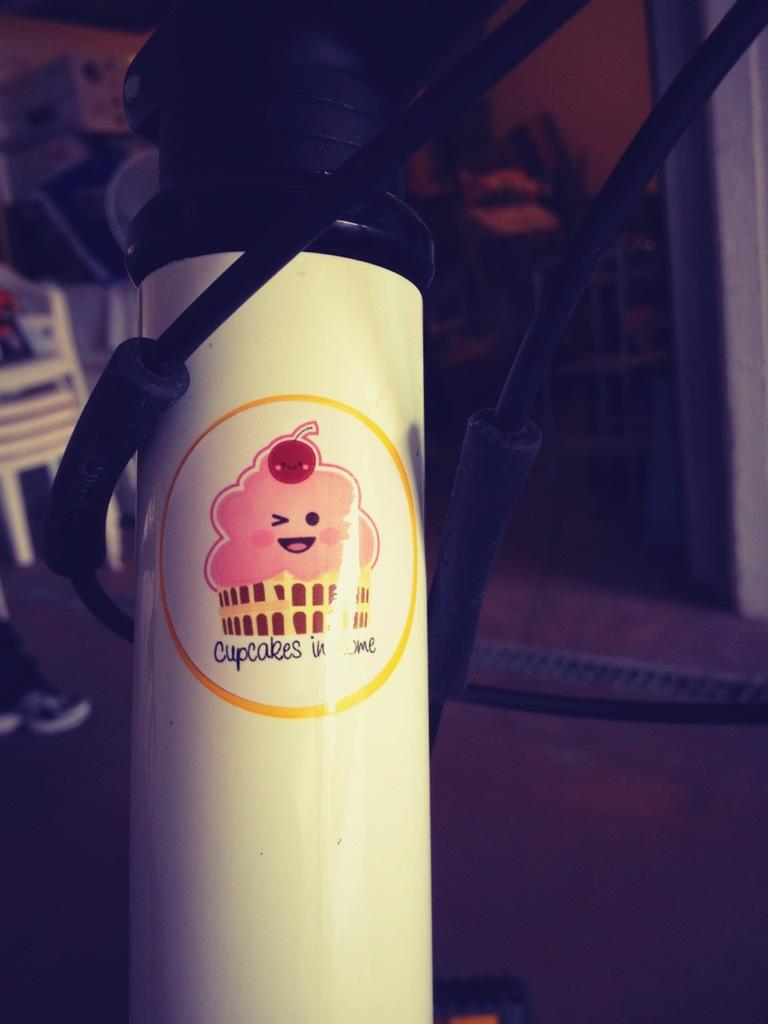What confection is the cartoon representing?
Offer a terse response. Cupcakes. What's right beow the cartoon image?
Provide a short and direct response. Cupcakes in rome. 